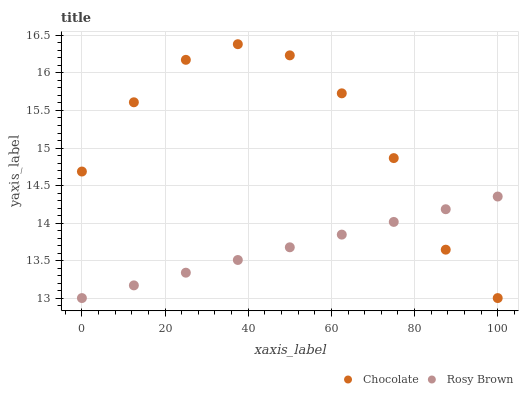Does Rosy Brown have the minimum area under the curve?
Answer yes or no. Yes. Does Chocolate have the maximum area under the curve?
Answer yes or no. Yes. Does Chocolate have the minimum area under the curve?
Answer yes or no. No. Is Rosy Brown the smoothest?
Answer yes or no. Yes. Is Chocolate the roughest?
Answer yes or no. Yes. Is Chocolate the smoothest?
Answer yes or no. No. Does Rosy Brown have the lowest value?
Answer yes or no. Yes. Does Chocolate have the highest value?
Answer yes or no. Yes. Does Rosy Brown intersect Chocolate?
Answer yes or no. Yes. Is Rosy Brown less than Chocolate?
Answer yes or no. No. Is Rosy Brown greater than Chocolate?
Answer yes or no. No. 